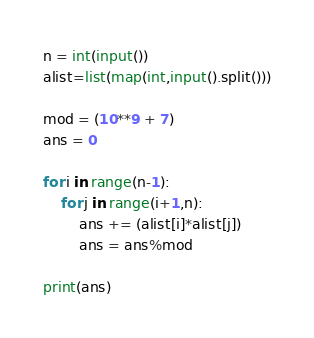Convert code to text. <code><loc_0><loc_0><loc_500><loc_500><_Python_>n = int(input())
alist=list(map(int,input().split()))

mod = (10**9 + 7)
ans = 0

for i in range(n-1):
    for j in range(i+1,n):
        ans += (alist[i]*alist[j])
        ans = ans%mod

print(ans)</code> 